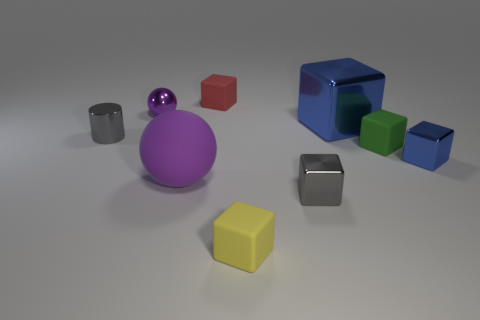Imagine if these objects were part of a child's playset, how would you describe the play patterns that could be enjoyed? If these objects were part of a child's playset, I'd imagine they could be used to create a vibrant, colorful landscape. The child could stack the cubes and balls to build imaginative structures or sort them by size and color for a fun and educational activity. They might also be used to teach concepts like 'behind' and 'in front of' with the positioning of the objects, or 'bigger' and 'smaller' with the varying sizes of the spheres and cubes. 